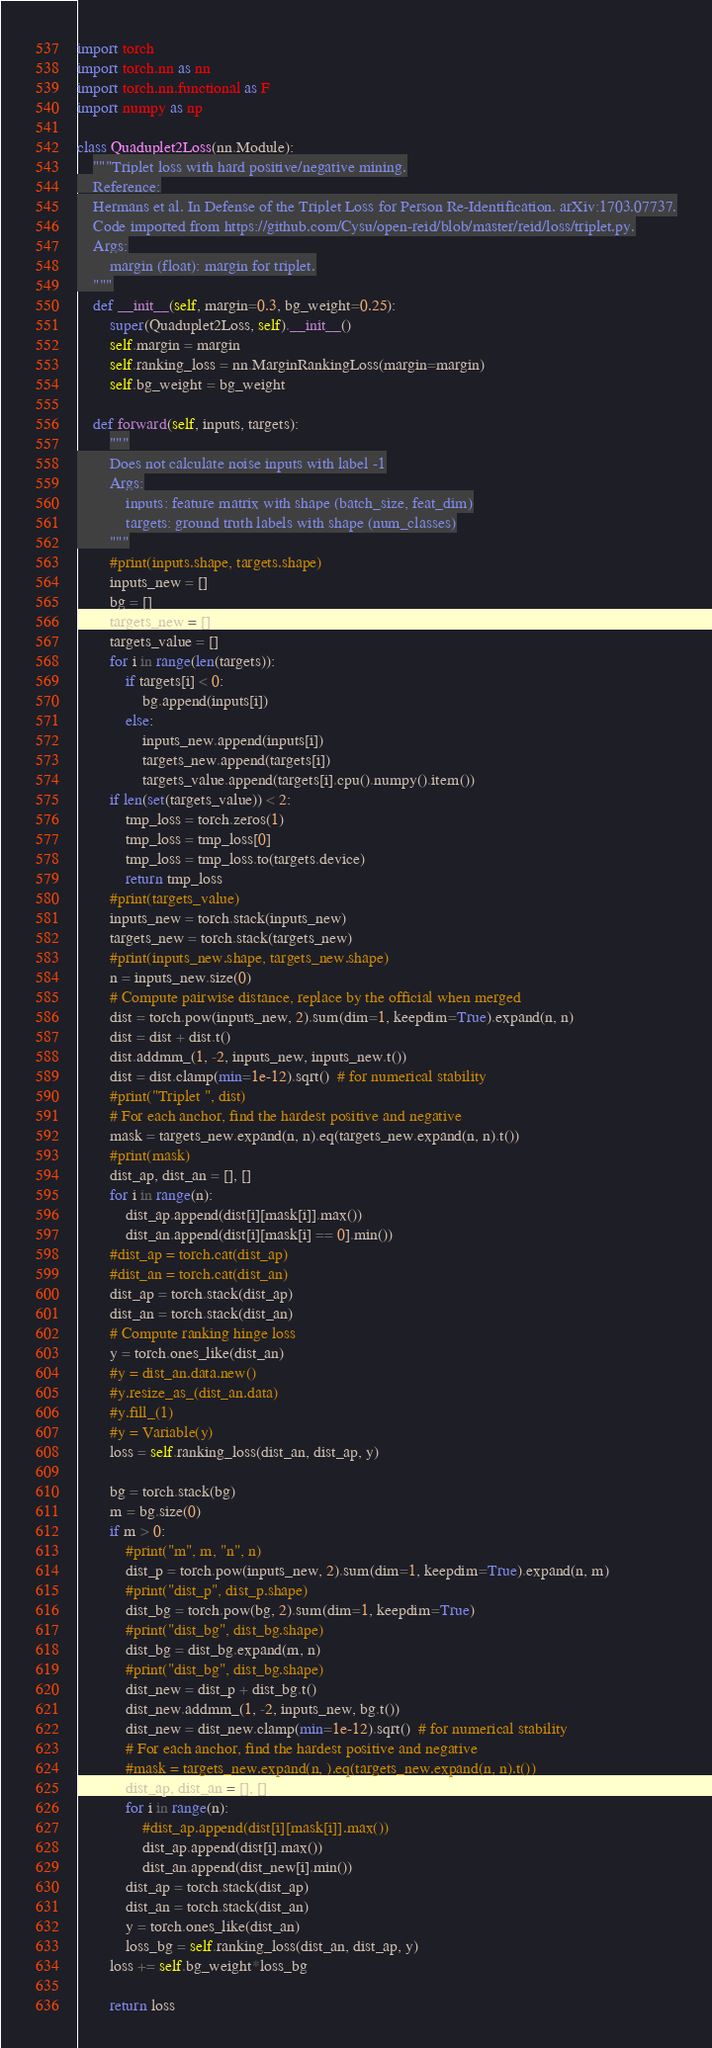<code> <loc_0><loc_0><loc_500><loc_500><_Python_>import torch
import torch.nn as nn
import torch.nn.functional as F
import numpy as np

class Quaduplet2Loss(nn.Module):
    """Triplet loss with hard positive/negative mining.
    Reference:
    Hermans et al. In Defense of the Triplet Loss for Person Re-Identification. arXiv:1703.07737.
    Code imported from https://github.com/Cysu/open-reid/blob/master/reid/loss/triplet.py.
    Args:
        margin (float): margin for triplet.
    """
    def __init__(self, margin=0.3, bg_weight=0.25):
        super(Quaduplet2Loss, self).__init__()
        self.margin = margin
        self.ranking_loss = nn.MarginRankingLoss(margin=margin)
        self.bg_weight = bg_weight

    def forward(self, inputs, targets):
        """
        Does not calculate noise inputs with label -1
        Args:
            inputs: feature matrix with shape (batch_size, feat_dim)
            targets: ground truth labels with shape (num_classes)
        """
        #print(inputs.shape, targets.shape)
        inputs_new = []
        bg = []
        targets_new = []
        targets_value = []
        for i in range(len(targets)):
            if targets[i] < 0:
                bg.append(inputs[i])
            else:
                inputs_new.append(inputs[i])
                targets_new.append(targets[i])
                targets_value.append(targets[i].cpu().numpy().item())
        if len(set(targets_value)) < 2:
            tmp_loss = torch.zeros(1)
            tmp_loss = tmp_loss[0]
            tmp_loss = tmp_loss.to(targets.device)
            return tmp_loss
        #print(targets_value)
        inputs_new = torch.stack(inputs_new)
        targets_new = torch.stack(targets_new)
        #print(inputs_new.shape, targets_new.shape)
        n = inputs_new.size(0)
        # Compute pairwise distance, replace by the official when merged
        dist = torch.pow(inputs_new, 2).sum(dim=1, keepdim=True).expand(n, n)
        dist = dist + dist.t()
        dist.addmm_(1, -2, inputs_new, inputs_new.t())
        dist = dist.clamp(min=1e-12).sqrt()  # for numerical stability
        #print("Triplet ", dist)
        # For each anchor, find the hardest positive and negative
        mask = targets_new.expand(n, n).eq(targets_new.expand(n, n).t())
        #print(mask)
        dist_ap, dist_an = [], []
        for i in range(n):
            dist_ap.append(dist[i][mask[i]].max())
            dist_an.append(dist[i][mask[i] == 0].min())
        #dist_ap = torch.cat(dist_ap)
        #dist_an = torch.cat(dist_an)
        dist_ap = torch.stack(dist_ap)
        dist_an = torch.stack(dist_an)
        # Compute ranking hinge loss
        y = torch.ones_like(dist_an)
        #y = dist_an.data.new()
        #y.resize_as_(dist_an.data)
        #y.fill_(1)
        #y = Variable(y)
        loss = self.ranking_loss(dist_an, dist_ap, y)

        bg = torch.stack(bg)
        m = bg.size(0)
        if m > 0:
            #print("m", m, "n", n)
            dist_p = torch.pow(inputs_new, 2).sum(dim=1, keepdim=True).expand(n, m)
            #print("dist_p", dist_p.shape)
            dist_bg = torch.pow(bg, 2).sum(dim=1, keepdim=True)
            #print("dist_bg", dist_bg.shape)
            dist_bg = dist_bg.expand(m, n)
            #print("dist_bg", dist_bg.shape)
            dist_new = dist_p + dist_bg.t()
            dist_new.addmm_(1, -2, inputs_new, bg.t())
            dist_new = dist_new.clamp(min=1e-12).sqrt()  # for numerical stability
            # For each anchor, find the hardest positive and negative
            #mask = targets_new.expand(n, ).eq(targets_new.expand(n, n).t())
            dist_ap, dist_an = [], []
            for i in range(n):
                #dist_ap.append(dist[i][mask[i]].max())
                dist_ap.append(dist[i].max())
                dist_an.append(dist_new[i].min())
            dist_ap = torch.stack(dist_ap)
            dist_an = torch.stack(dist_an)
            y = torch.ones_like(dist_an)
            loss_bg = self.ranking_loss(dist_an, dist_ap, y)
        loss += self.bg_weight*loss_bg

        return loss</code> 